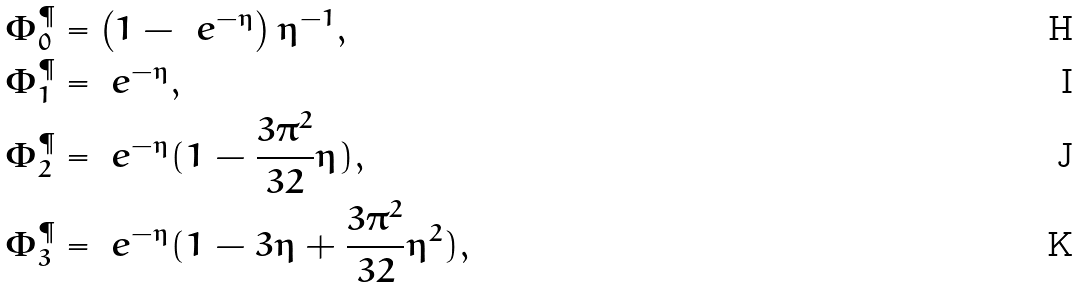<formula> <loc_0><loc_0><loc_500><loc_500>\Phi _ { 0 } ^ { \P } & = \left ( 1 - \ e ^ { - \eta } \right ) \eta ^ { - 1 } , \\ \Phi _ { 1 } ^ { \P } & = \ e ^ { - \eta } , \\ \Phi _ { 2 } ^ { \P } & = \ e ^ { - \eta } ( 1 - \frac { 3 \pi ^ { 2 } } { 3 2 } \eta ) , \\ \Phi _ { 3 } ^ { \P } & = \ e ^ { - \eta } ( 1 - 3 \eta + \frac { 3 \pi ^ { 2 } } { 3 2 } \eta ^ { 2 } ) ,</formula> 